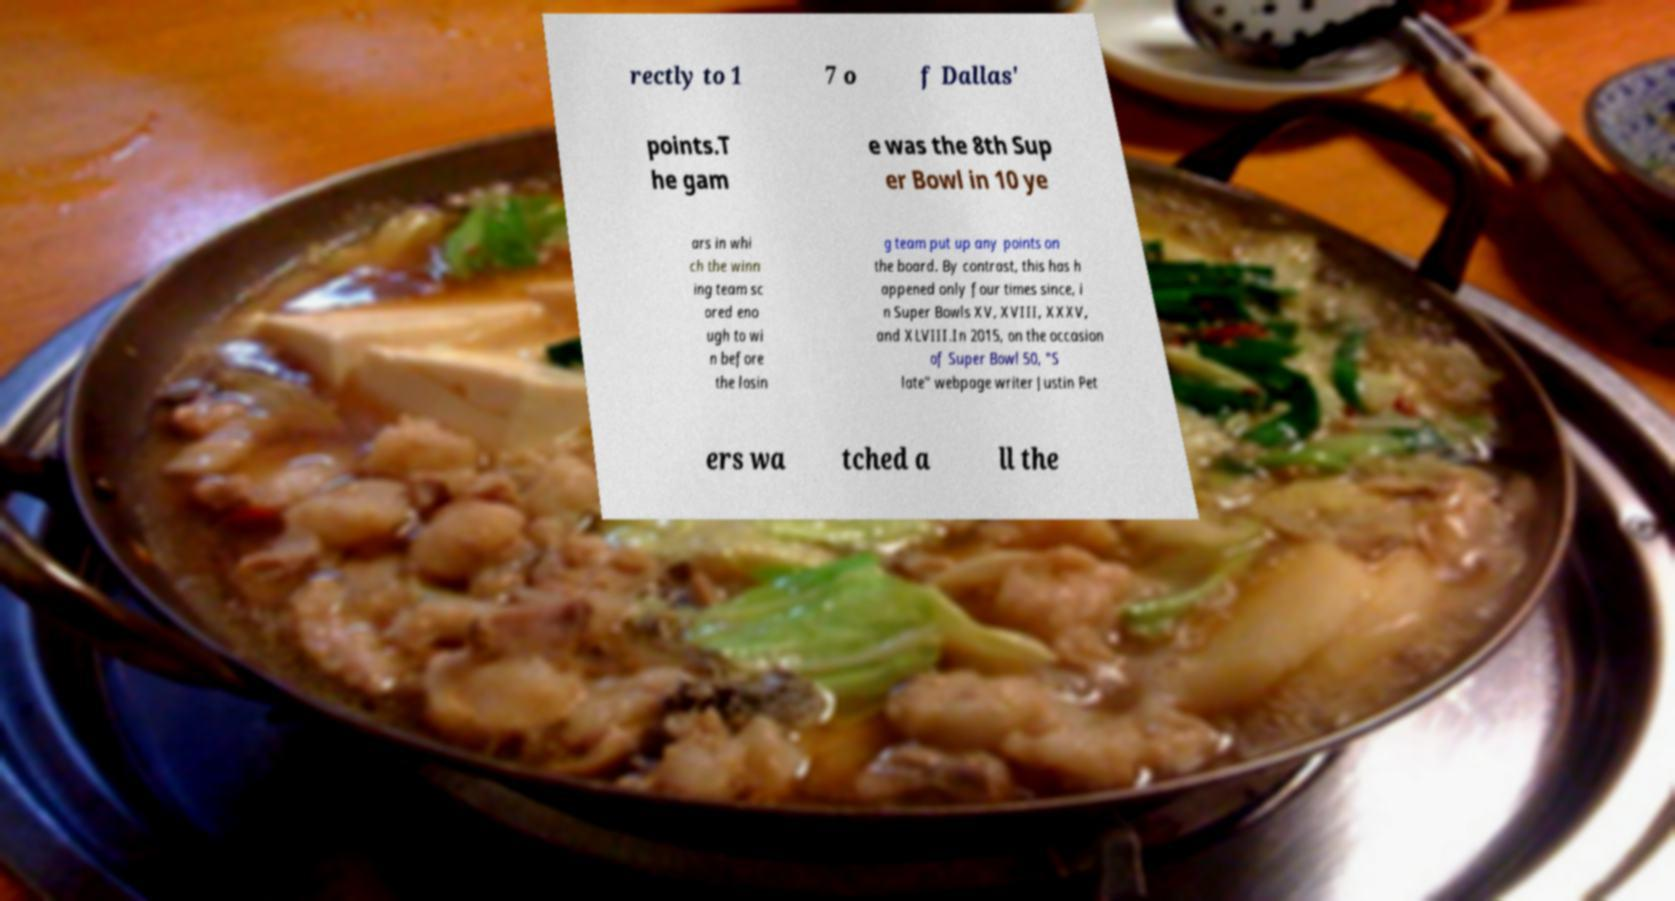Can you accurately transcribe the text from the provided image for me? rectly to 1 7 o f Dallas' points.T he gam e was the 8th Sup er Bowl in 10 ye ars in whi ch the winn ing team sc ored eno ugh to wi n before the losin g team put up any points on the board. By contrast, this has h appened only four times since, i n Super Bowls XV, XVIII, XXXV, and XLVIII.In 2015, on the occasion of Super Bowl 50, "S late" webpage writer Justin Pet ers wa tched a ll the 